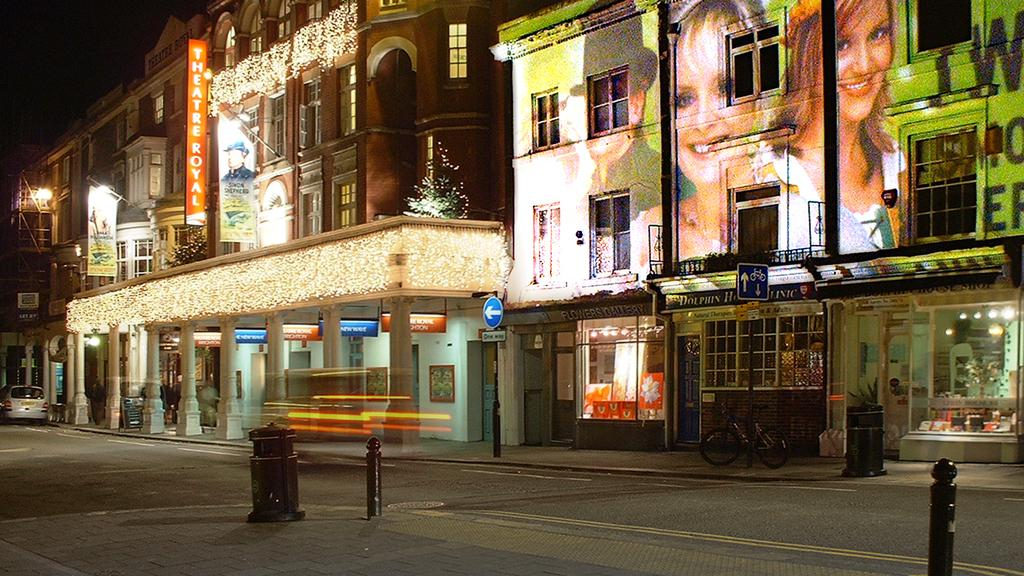What type of structures can be seen in the image? There are buildings in the image. What feature do the buildings have? The buildings have windows. What else can be seen in the image besides the buildings? There are boards, a bicycle, and doors visible in the image. What is written on the boards? Something is written on the boards. Are there any people visible in the image? Faces of people are visible in the image. What color is the orange that is being peeled by the person in the image? There is no orange present in the image; it only features buildings, boards, a bicycle, doors, and faces of people. 